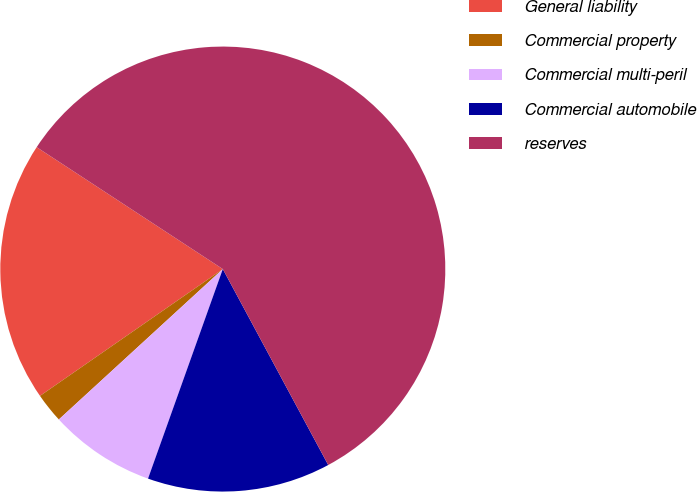<chart> <loc_0><loc_0><loc_500><loc_500><pie_chart><fcel>General liability<fcel>Commercial property<fcel>Commercial multi-peril<fcel>Commercial automobile<fcel>reserves<nl><fcel>18.88%<fcel>2.16%<fcel>7.73%<fcel>13.31%<fcel>57.91%<nl></chart> 